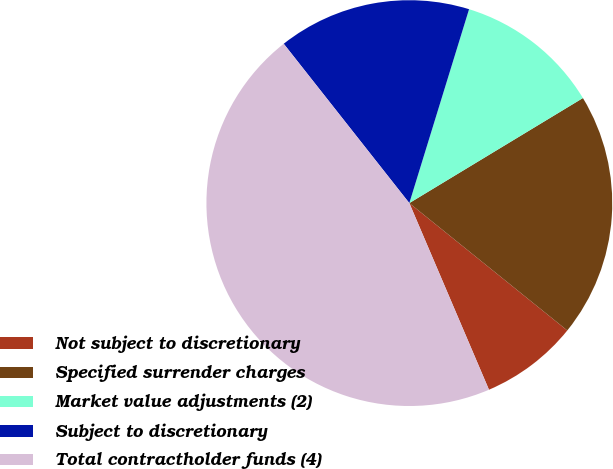<chart> <loc_0><loc_0><loc_500><loc_500><pie_chart><fcel>Not subject to discretionary<fcel>Specified surrender charges<fcel>Market value adjustments (2)<fcel>Subject to discretionary<fcel>Total contractholder funds (4)<nl><fcel>7.78%<fcel>19.46%<fcel>11.58%<fcel>15.38%<fcel>45.79%<nl></chart> 